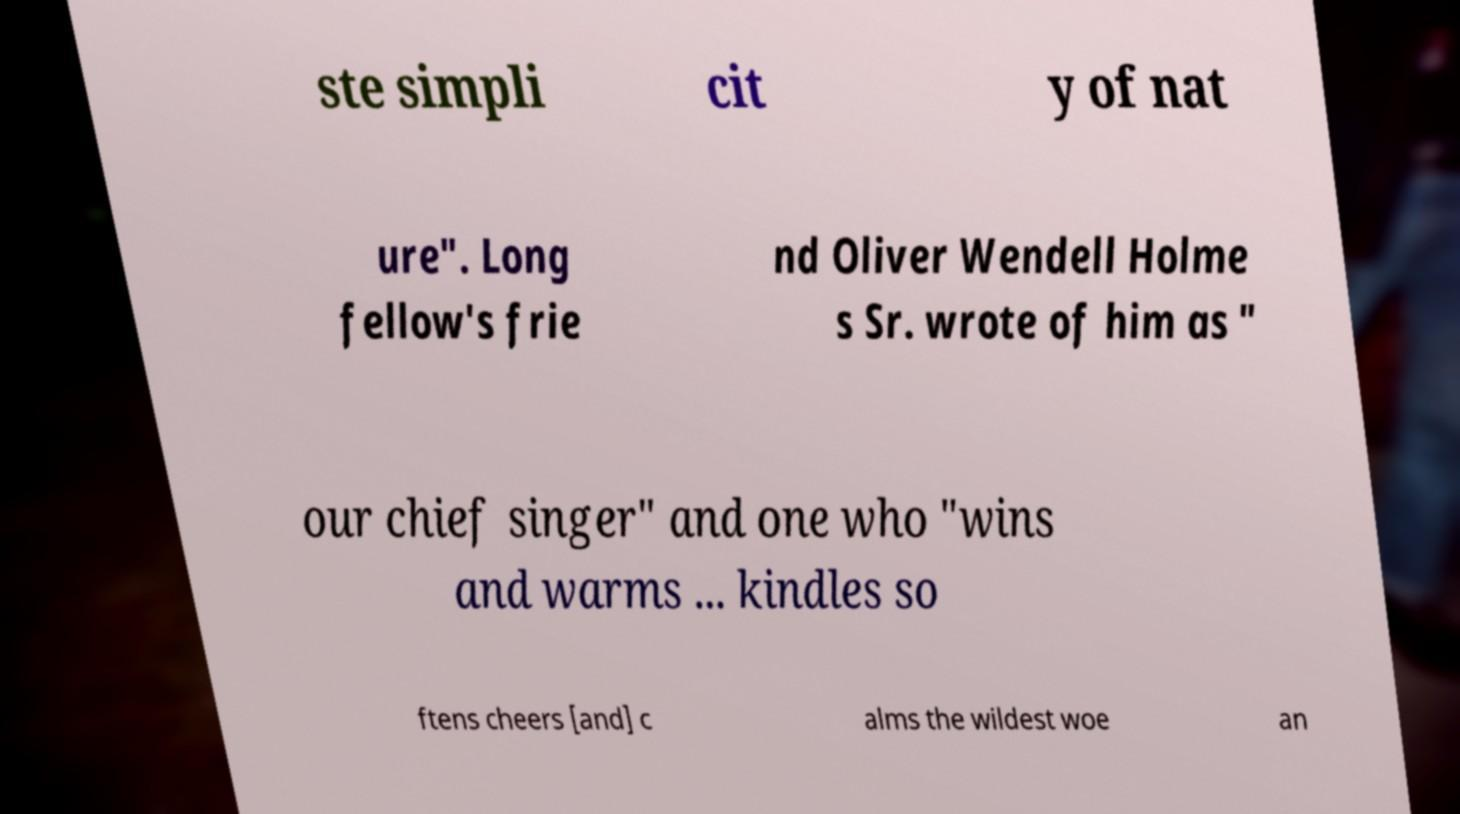There's text embedded in this image that I need extracted. Can you transcribe it verbatim? ste simpli cit y of nat ure". Long fellow's frie nd Oliver Wendell Holme s Sr. wrote of him as " our chief singer" and one who "wins and warms ... kindles so ftens cheers [and] c alms the wildest woe an 